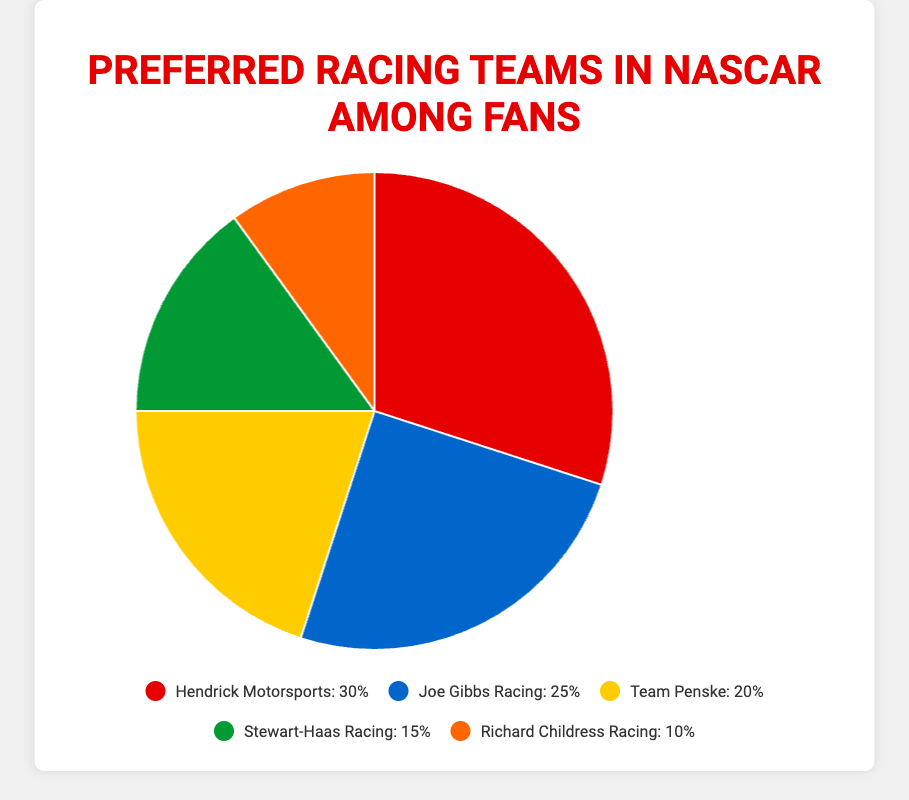What's the most popular racing team among fans? The team with the highest percentage in the pie chart is the most popular. Hendrick Motorsports has the largest slice at 30%.
Answer: Hendrick Motorsports Which team is more preferred, Joe Gibbs Racing or Team Penske? By looking at the percentages, Joe Gibbs Racing is preferred by 25% while Team Penske is preferred by 20%.
Answer: Joe Gibbs Racing What's the combined preference percentage for Stewart-Haas Racing and Richard Childress Racing? Add the percentage for Stewart-Haas Racing (15%) and Richard Childress Racing (10%). The combined percentage is 15% + 10% = 25%.
Answer: 25% Which colors represent the teams with the highest and lowest fan preference? The red slice represents Hendrick Motorsports (30%, highest), and the orange slice represents Richard Childress Racing (10%, lowest).
Answer: Red and Orange What's the difference in preference percentage between the most and least popular teams? Subtract the percentage of the least popular team from the most popular team: 30% (Hendrick Motorsports) - 10% (Richard Childress Racing) = 20%.
Answer: 20% Among the five teams, which teams have preference percentages that are above 20%? Identify the teams with percentages above 20%: Hendrick Motorsports (30%) and Joe Gibbs Racing (25%).
Answer: Hendrick Motorsports and Joe Gibbs Racing Which team's slice would you find in blue color? The blue slice represents Joe Gibbs Racing according to the legend.
Answer: Joe Gibbs Racing How do the combined percentages of Hendrick Motorsports and Joe Gibbs Racing compare to the total percentage of the remaining three teams? Sum the percentages of Hendrick Motorsports (30%) and Joe Gibbs Racing (25%) to compare with the sum of the other three teams (Team Penske 20% + Stewart-Haas Racing 15% + Richard Childress Racing 10%). Hendrick Motorsports and Joe Gibbs Racing together have 30% + 25% = 55%, which is greater than the total of the remaining teams (20% + 15% + 10% = 45%).
Answer: 55% vs 45% Which team is represented by the green slice, and what is its preference percentage? The green slice represents Stewart-Haas Racing with a preference percentage of 15%.
Answer: Stewart-Haas Racing, 15% What's the difference in preference percentage between Joe Gibbs Racing and Team Penske? Subtract the preference percentage of Team Penske from Joe Gibbs Racing: 25% - 20% = 5%.
Answer: 5% 